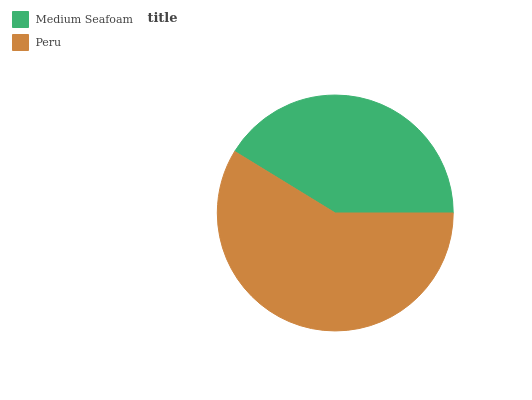Is Medium Seafoam the minimum?
Answer yes or no. Yes. Is Peru the maximum?
Answer yes or no. Yes. Is Peru the minimum?
Answer yes or no. No. Is Peru greater than Medium Seafoam?
Answer yes or no. Yes. Is Medium Seafoam less than Peru?
Answer yes or no. Yes. Is Medium Seafoam greater than Peru?
Answer yes or no. No. Is Peru less than Medium Seafoam?
Answer yes or no. No. Is Peru the high median?
Answer yes or no. Yes. Is Medium Seafoam the low median?
Answer yes or no. Yes. Is Medium Seafoam the high median?
Answer yes or no. No. Is Peru the low median?
Answer yes or no. No. 